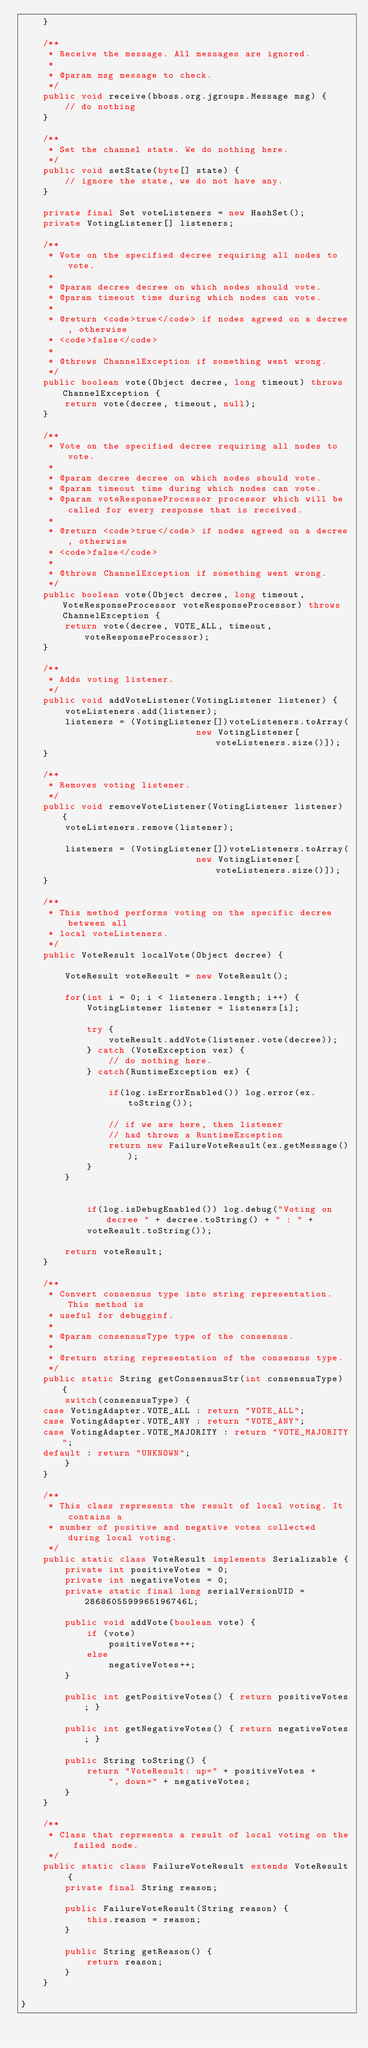<code> <loc_0><loc_0><loc_500><loc_500><_Java_>    }

    /**
     * Receive the message. All messages are ignored.
     *
     * @param msg message to check.
     */
    public void receive(bboss.org.jgroups.Message msg) {
        // do nothing
    }

    /**
     * Set the channel state. We do nothing here.
     */
    public void setState(byte[] state) {
        // ignore the state, we do not have any.
    }

    private final Set voteListeners = new HashSet();
    private VotingListener[] listeners;

    /**
     * Vote on the specified decree requiring all nodes to vote.
     * 
     * @param decree decree on which nodes should vote.
     * @param timeout time during which nodes can vote.
     * 
     * @return <code>true</code> if nodes agreed on a decree, otherwise 
     * <code>false</code>
     * 
     * @throws ChannelException if something went wrong.
     */
    public boolean vote(Object decree, long timeout) throws ChannelException {
        return vote(decree, timeout, null);
    }

    /**
     * Vote on the specified decree requiring all nodes to vote.
     * 
     * @param decree decree on which nodes should vote.
     * @param timeout time during which nodes can vote.
     * @param voteResponseProcessor processor which will be called for every response that is received.
     * 
     * @return <code>true</code> if nodes agreed on a decree, otherwise 
     * <code>false</code>
     * 
     * @throws ChannelException if something went wrong.
     */
    public boolean vote(Object decree, long timeout, VoteResponseProcessor voteResponseProcessor) throws ChannelException {
        return vote(decree, VOTE_ALL, timeout, voteResponseProcessor);
    }

    /**
     * Adds voting listener.
     */
    public void addVoteListener(VotingListener listener) {
        voteListeners.add(listener);
        listeners = (VotingListener[])voteListeners.toArray(
                                new VotingListener[voteListeners.size()]);
    }

    /**
     * Removes voting listener.
     */
    public void removeVoteListener(VotingListener listener) {
        voteListeners.remove(listener);

        listeners = (VotingListener[])voteListeners.toArray(
                                new VotingListener[voteListeners.size()]);
    }

    /**
     * This method performs voting on the specific decree between all
     * local voteListeners.
     */
    public VoteResult localVote(Object decree) {

        VoteResult voteResult = new VoteResult();

        for(int i = 0; i < listeners.length; i++) {
            VotingListener listener = listeners[i];

            try {
                voteResult.addVote(listener.vote(decree));
            } catch (VoteException vex) {
                // do nothing here.
            } catch(RuntimeException ex) {

                if(log.isErrorEnabled()) log.error(ex.toString());

                // if we are here, then listener 
                // had thrown a RuntimeException
                return new FailureVoteResult(ex.getMessage());
            }
        }


            if(log.isDebugEnabled()) log.debug("Voting on decree " + decree.toString() + " : " +
            voteResult.toString());

        return voteResult;
    }

    /**
     * Convert consensus type into string representation. This method is 
     * useful for debugginf.
     * 
     * @param consensusType type of the consensus.
     * 
     * @return string representation of the consensus type.
     */
    public static String getConsensusStr(int consensusType) {
        switch(consensusType) {
    case VotingAdapter.VOTE_ALL : return "VOTE_ALL";
    case VotingAdapter.VOTE_ANY : return "VOTE_ANY";
    case VotingAdapter.VOTE_MAJORITY : return "VOTE_MAJORITY";
    default : return "UNKNOWN";
        }
    }

    /**
     * This class represents the result of local voting. It contains a 
     * number of positive and negative votes collected during local voting.
     */
    public static class VoteResult implements Serializable {
        private int positiveVotes = 0;
        private int negativeVotes = 0;
        private static final long serialVersionUID = 2868605599965196746L;

        public void addVote(boolean vote) {
            if (vote)
                positiveVotes++;
            else
                negativeVotes++;
        }

        public int getPositiveVotes() { return positiveVotes; }

        public int getNegativeVotes() { return negativeVotes; }

        public String toString() {
            return "VoteResult: up=" + positiveVotes +
                ", down=" + negativeVotes;
        }
    }

    /**
     * Class that represents a result of local voting on the failed node.
     */
    public static class FailureVoteResult extends VoteResult {
        private final String reason;

        public FailureVoteResult(String reason) {
            this.reason = reason;
        }

        public String getReason() {
            return reason;
        }
    }

}
</code> 